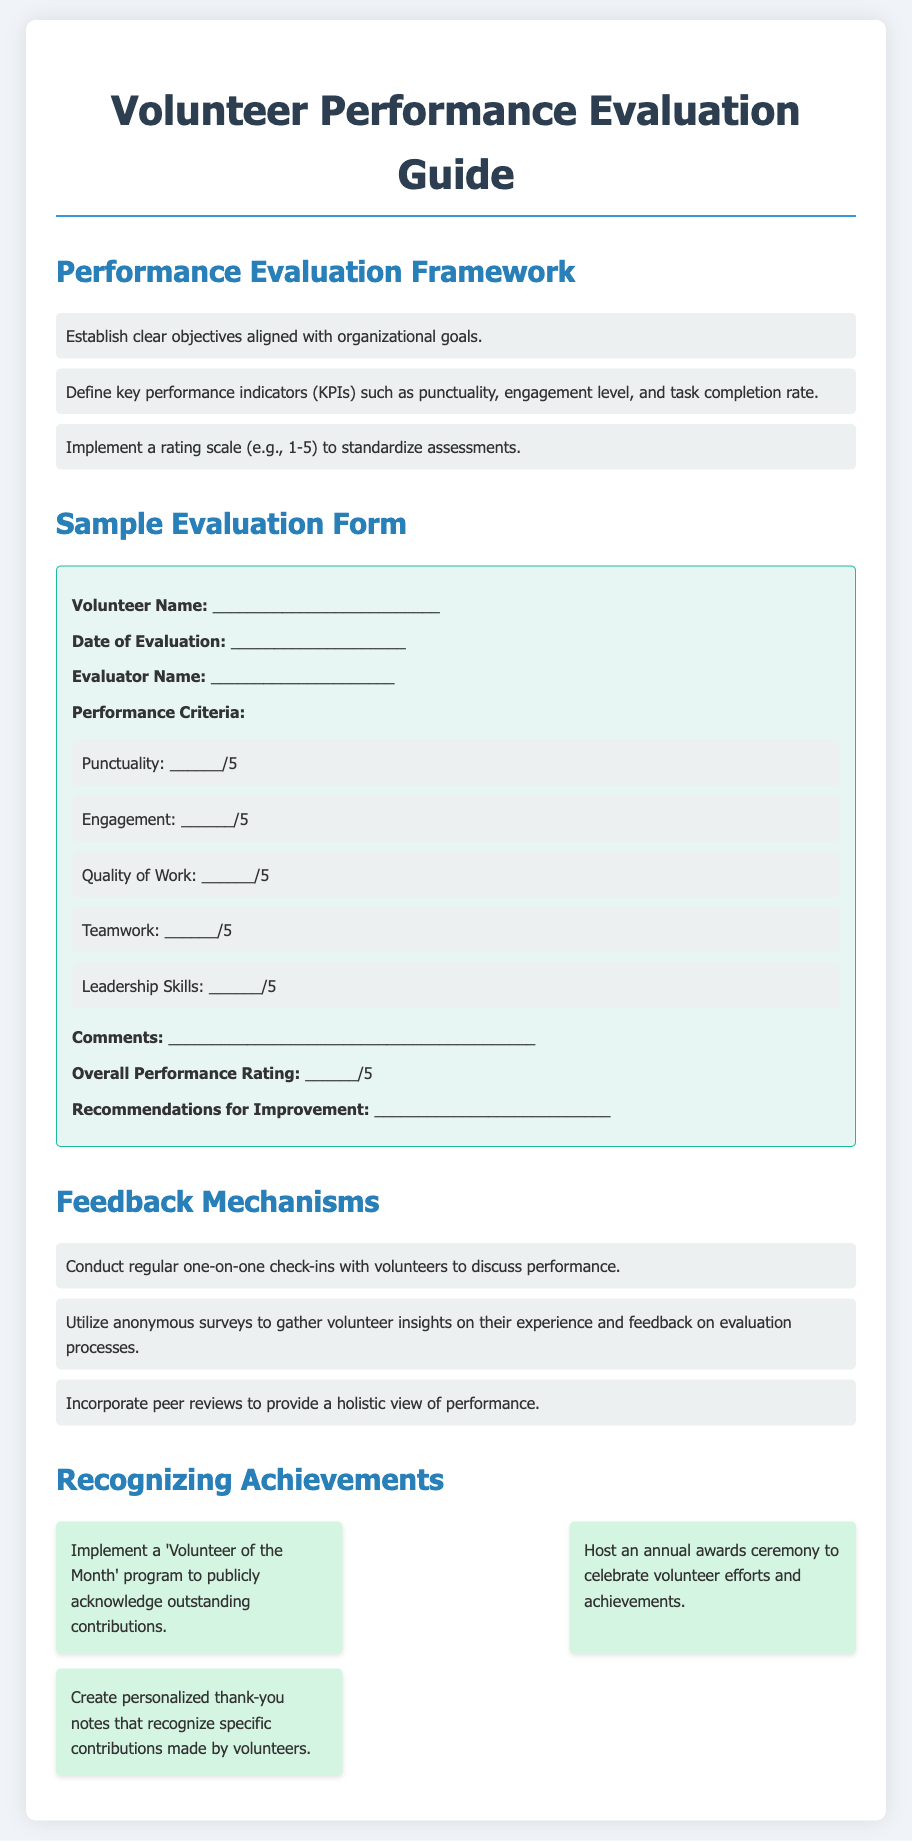What is the title of the document? The title is the main heading of the document, which is prominently displayed at the top.
Answer: Volunteer Performance Evaluation Guide What is the maximum score for the 'Punctuality' criterion in the evaluation form? The score for each performance criterion in the sample evaluation form ranges from 1 to 5.
Answer: 5 What are the three key performance indicators (KPIs) listed in the evaluation framework? The KPIs are specific metrics used to assess volunteer performance, which are mentioned in the performance evaluation framework section.
Answer: Punctuality, engagement level, task completion rate How often should one-on-one check-ins be conducted according to the feedback mechanisms? This is implied to be a regular occurrence as mentioned in the feedback mechanisms section of the document.
Answer: Regularly What is one method suggested for recognizing volunteer achievements? The document outlines several strategies for acknowledging volunteers, which include specific approaches.
Answer: Volunteer of the Month program 